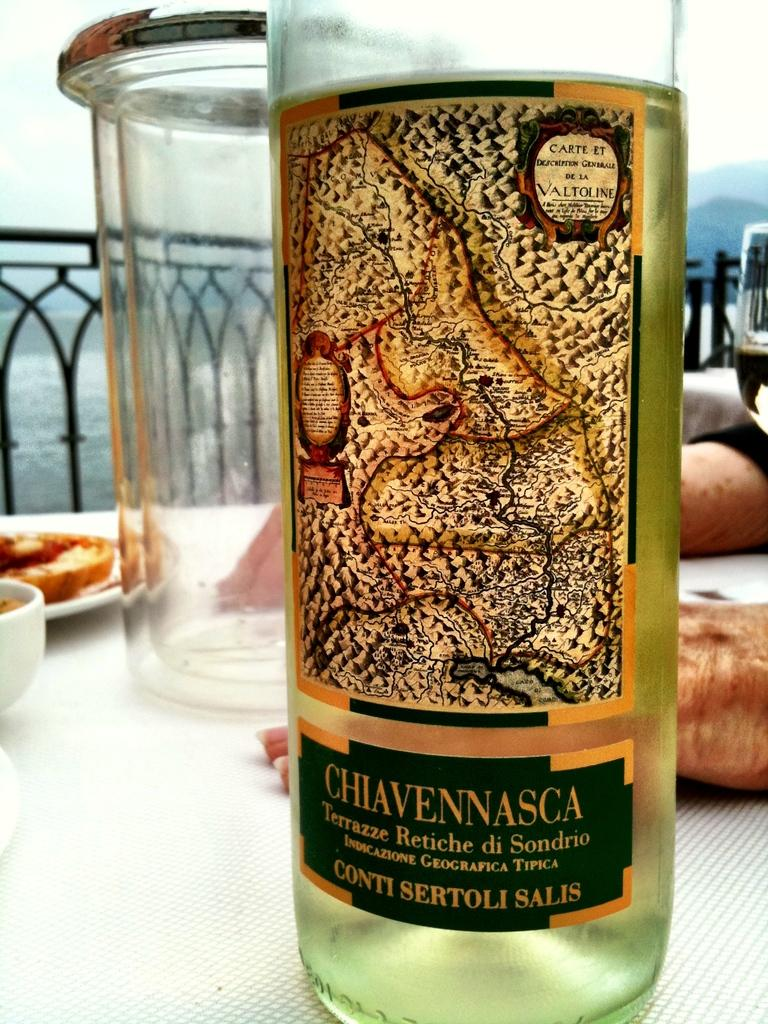What type of beverage container is in the image? There is a wine bottle in the image. What is likely to be used for drinking the wine? There is a glass in the image that can be used for drinking the wine. What food items are present in the image? There are eatables on a plate in the image. Where are the wine bottle, glass, and plate located? The wine bottle, glass, and plate are on a table. What else can be seen beside the wine bottle? There are two hands beside the wine bottle. What type of education is being provided in the image? There is no indication of any educational activity in the image; it primarily features a wine bottle, glass, plate, and hands. 